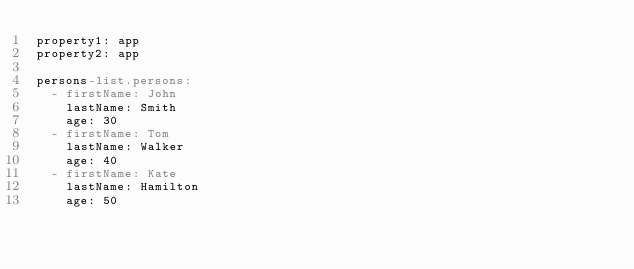<code> <loc_0><loc_0><loc_500><loc_500><_YAML_>property1: app
property2: app

persons-list.persons:
  - firstName: John
    lastName: Smith
    age: 30
  - firstName: Tom
    lastName: Walker
    age: 40
  - firstName: Kate
    lastName: Hamilton
    age: 50</code> 